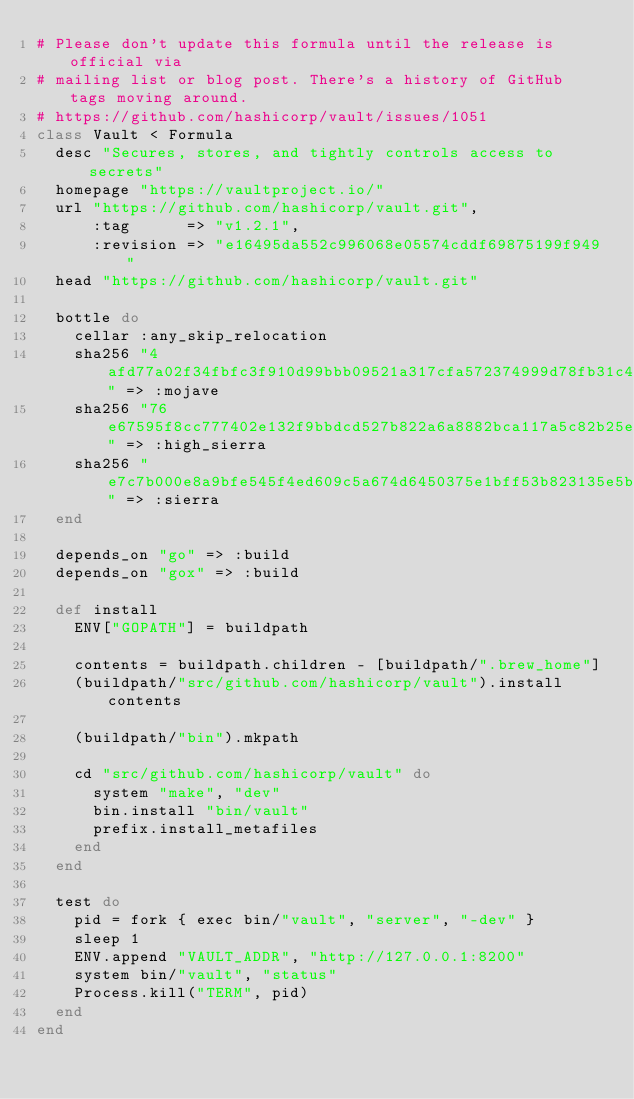<code> <loc_0><loc_0><loc_500><loc_500><_Ruby_># Please don't update this formula until the release is official via
# mailing list or blog post. There's a history of GitHub tags moving around.
# https://github.com/hashicorp/vault/issues/1051
class Vault < Formula
  desc "Secures, stores, and tightly controls access to secrets"
  homepage "https://vaultproject.io/"
  url "https://github.com/hashicorp/vault.git",
      :tag      => "v1.2.1",
      :revision => "e16495da552c996068e05574cddf69875199f949"
  head "https://github.com/hashicorp/vault.git"

  bottle do
    cellar :any_skip_relocation
    sha256 "4afd77a02f34fbfc3f910d99bbb09521a317cfa572374999d78fb31c46eb0c71" => :mojave
    sha256 "76e67595f8cc777402e132f9bbdcd527b822a6a8882bca117a5c82b25e899799" => :high_sierra
    sha256 "e7c7b000e8a9bfe545f4ed609c5a674d6450375e1bff53b823135e5b31d942c4" => :sierra
  end

  depends_on "go" => :build
  depends_on "gox" => :build

  def install
    ENV["GOPATH"] = buildpath

    contents = buildpath.children - [buildpath/".brew_home"]
    (buildpath/"src/github.com/hashicorp/vault").install contents

    (buildpath/"bin").mkpath

    cd "src/github.com/hashicorp/vault" do
      system "make", "dev"
      bin.install "bin/vault"
      prefix.install_metafiles
    end
  end

  test do
    pid = fork { exec bin/"vault", "server", "-dev" }
    sleep 1
    ENV.append "VAULT_ADDR", "http://127.0.0.1:8200"
    system bin/"vault", "status"
    Process.kill("TERM", pid)
  end
end
</code> 